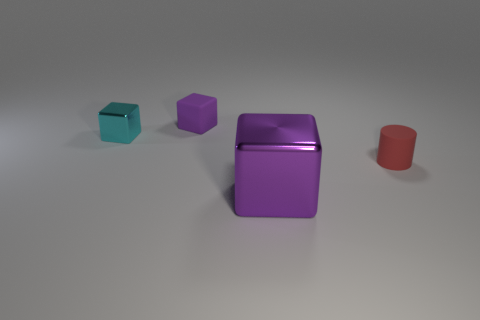Are there any other blocks that have the same color as the matte cube?
Offer a very short reply. Yes. What is the size of the metallic block that is the same color as the small matte cube?
Your response must be concise. Large. There is another object that is the same color as the big shiny object; what is its material?
Make the answer very short. Rubber. The thing that is on the right side of the tiny purple matte cube and behind the purple metallic thing has what shape?
Offer a very short reply. Cylinder. How many things are either matte cylinders right of the purple shiny object or matte objects that are right of the tiny purple matte cube?
Provide a short and direct response. 1. Are there an equal number of big purple metal things that are behind the purple shiny block and blocks that are right of the small cylinder?
Your response must be concise. Yes. There is a tiny object that is on the left side of the tiny rubber object behind the red rubber cylinder; what shape is it?
Provide a short and direct response. Cube. Are there any small purple objects that have the same shape as the cyan metal thing?
Make the answer very short. Yes. How many tiny yellow matte cubes are there?
Give a very brief answer. 0. Does the block in front of the red matte cylinder have the same material as the small cyan thing?
Make the answer very short. Yes. 